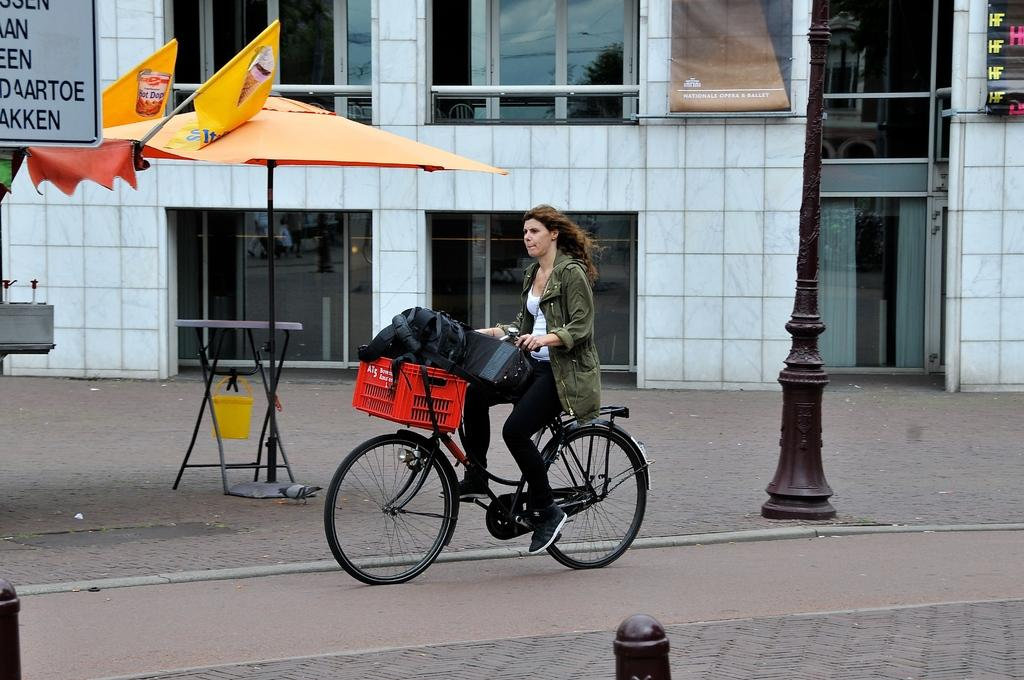Who is the person in the image? There is a woman in the image. What is the woman doing in the image? The woman is cycling a bicycle. Where is the bicycle located in the image? The bicycle is on the road. What structures can be seen in the image? There is a building and a tent in the image. What else is present in the image? There is a pole in the image. What type of beef is being displayed in the image? There is no beef present in the image. 